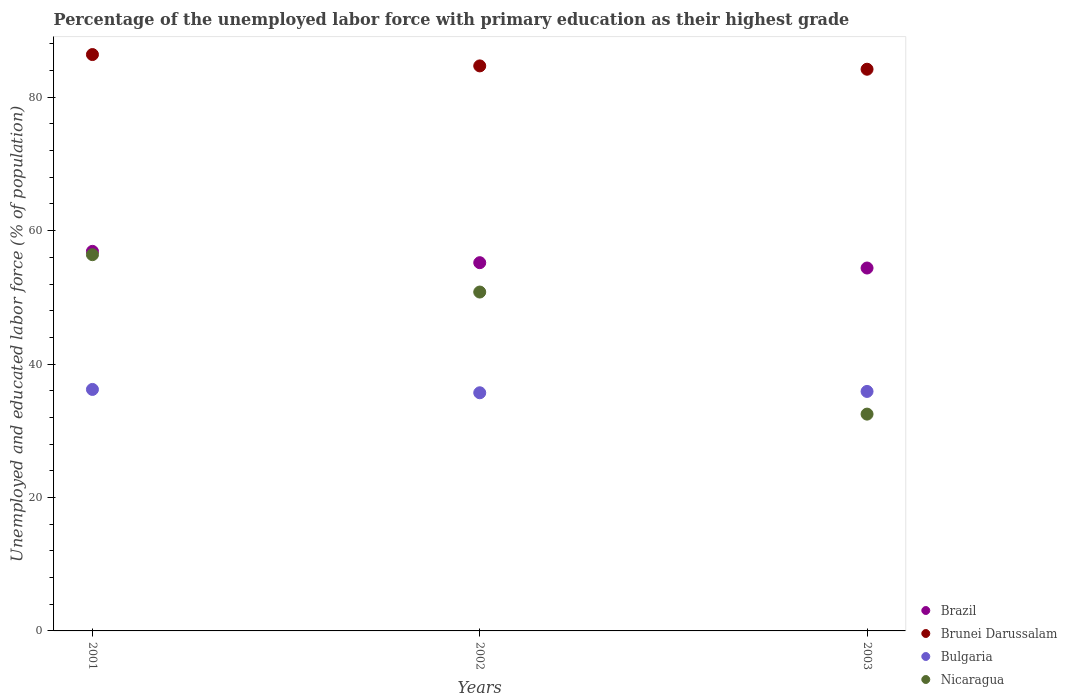How many different coloured dotlines are there?
Your answer should be very brief. 4. What is the percentage of the unemployed labor force with primary education in Nicaragua in 2002?
Provide a succinct answer. 50.8. Across all years, what is the maximum percentage of the unemployed labor force with primary education in Bulgaria?
Keep it short and to the point. 36.2. Across all years, what is the minimum percentage of the unemployed labor force with primary education in Nicaragua?
Your answer should be compact. 32.5. In which year was the percentage of the unemployed labor force with primary education in Nicaragua minimum?
Provide a short and direct response. 2003. What is the total percentage of the unemployed labor force with primary education in Brazil in the graph?
Give a very brief answer. 166.5. What is the difference between the percentage of the unemployed labor force with primary education in Brunei Darussalam in 2001 and that in 2002?
Make the answer very short. 1.7. What is the difference between the percentage of the unemployed labor force with primary education in Brunei Darussalam in 2002 and the percentage of the unemployed labor force with primary education in Brazil in 2001?
Offer a terse response. 27.8. What is the average percentage of the unemployed labor force with primary education in Nicaragua per year?
Offer a terse response. 46.57. In the year 2003, what is the difference between the percentage of the unemployed labor force with primary education in Bulgaria and percentage of the unemployed labor force with primary education in Nicaragua?
Ensure brevity in your answer.  3.4. In how many years, is the percentage of the unemployed labor force with primary education in Brazil greater than 40 %?
Your answer should be very brief. 3. What is the ratio of the percentage of the unemployed labor force with primary education in Bulgaria in 2001 to that in 2003?
Offer a terse response. 1.01. Is the percentage of the unemployed labor force with primary education in Brazil in 2002 less than that in 2003?
Your answer should be very brief. No. What is the difference between the highest and the second highest percentage of the unemployed labor force with primary education in Brazil?
Keep it short and to the point. 1.7. What is the difference between the highest and the lowest percentage of the unemployed labor force with primary education in Bulgaria?
Make the answer very short. 0.5. In how many years, is the percentage of the unemployed labor force with primary education in Brunei Darussalam greater than the average percentage of the unemployed labor force with primary education in Brunei Darussalam taken over all years?
Your answer should be very brief. 1. Is it the case that in every year, the sum of the percentage of the unemployed labor force with primary education in Nicaragua and percentage of the unemployed labor force with primary education in Brazil  is greater than the sum of percentage of the unemployed labor force with primary education in Brunei Darussalam and percentage of the unemployed labor force with primary education in Bulgaria?
Ensure brevity in your answer.  Yes. Is the percentage of the unemployed labor force with primary education in Brunei Darussalam strictly greater than the percentage of the unemployed labor force with primary education in Nicaragua over the years?
Ensure brevity in your answer.  Yes. Is the percentage of the unemployed labor force with primary education in Bulgaria strictly less than the percentage of the unemployed labor force with primary education in Brazil over the years?
Offer a very short reply. Yes. What is the difference between two consecutive major ticks on the Y-axis?
Your answer should be compact. 20. Are the values on the major ticks of Y-axis written in scientific E-notation?
Provide a succinct answer. No. What is the title of the graph?
Offer a very short reply. Percentage of the unemployed labor force with primary education as their highest grade. What is the label or title of the X-axis?
Your answer should be compact. Years. What is the label or title of the Y-axis?
Provide a short and direct response. Unemployed and educated labor force (% of population). What is the Unemployed and educated labor force (% of population) in Brazil in 2001?
Provide a short and direct response. 56.9. What is the Unemployed and educated labor force (% of population) in Brunei Darussalam in 2001?
Give a very brief answer. 86.4. What is the Unemployed and educated labor force (% of population) of Bulgaria in 2001?
Give a very brief answer. 36.2. What is the Unemployed and educated labor force (% of population) of Nicaragua in 2001?
Keep it short and to the point. 56.4. What is the Unemployed and educated labor force (% of population) of Brazil in 2002?
Your answer should be very brief. 55.2. What is the Unemployed and educated labor force (% of population) of Brunei Darussalam in 2002?
Your response must be concise. 84.7. What is the Unemployed and educated labor force (% of population) in Bulgaria in 2002?
Offer a terse response. 35.7. What is the Unemployed and educated labor force (% of population) of Nicaragua in 2002?
Your response must be concise. 50.8. What is the Unemployed and educated labor force (% of population) in Brazil in 2003?
Provide a succinct answer. 54.4. What is the Unemployed and educated labor force (% of population) of Brunei Darussalam in 2003?
Offer a terse response. 84.2. What is the Unemployed and educated labor force (% of population) in Bulgaria in 2003?
Your answer should be compact. 35.9. What is the Unemployed and educated labor force (% of population) of Nicaragua in 2003?
Your response must be concise. 32.5. Across all years, what is the maximum Unemployed and educated labor force (% of population) in Brazil?
Your response must be concise. 56.9. Across all years, what is the maximum Unemployed and educated labor force (% of population) of Brunei Darussalam?
Provide a succinct answer. 86.4. Across all years, what is the maximum Unemployed and educated labor force (% of population) of Bulgaria?
Provide a succinct answer. 36.2. Across all years, what is the maximum Unemployed and educated labor force (% of population) of Nicaragua?
Ensure brevity in your answer.  56.4. Across all years, what is the minimum Unemployed and educated labor force (% of population) in Brazil?
Offer a very short reply. 54.4. Across all years, what is the minimum Unemployed and educated labor force (% of population) of Brunei Darussalam?
Make the answer very short. 84.2. Across all years, what is the minimum Unemployed and educated labor force (% of population) of Bulgaria?
Give a very brief answer. 35.7. Across all years, what is the minimum Unemployed and educated labor force (% of population) of Nicaragua?
Your response must be concise. 32.5. What is the total Unemployed and educated labor force (% of population) of Brazil in the graph?
Keep it short and to the point. 166.5. What is the total Unemployed and educated labor force (% of population) of Brunei Darussalam in the graph?
Make the answer very short. 255.3. What is the total Unemployed and educated labor force (% of population) in Bulgaria in the graph?
Give a very brief answer. 107.8. What is the total Unemployed and educated labor force (% of population) in Nicaragua in the graph?
Provide a short and direct response. 139.7. What is the difference between the Unemployed and educated labor force (% of population) of Brazil in 2001 and that in 2002?
Provide a succinct answer. 1.7. What is the difference between the Unemployed and educated labor force (% of population) in Nicaragua in 2001 and that in 2002?
Keep it short and to the point. 5.6. What is the difference between the Unemployed and educated labor force (% of population) in Brazil in 2001 and that in 2003?
Keep it short and to the point. 2.5. What is the difference between the Unemployed and educated labor force (% of population) of Bulgaria in 2001 and that in 2003?
Provide a short and direct response. 0.3. What is the difference between the Unemployed and educated labor force (% of population) in Nicaragua in 2001 and that in 2003?
Ensure brevity in your answer.  23.9. What is the difference between the Unemployed and educated labor force (% of population) of Brazil in 2002 and that in 2003?
Your answer should be very brief. 0.8. What is the difference between the Unemployed and educated labor force (% of population) in Brunei Darussalam in 2002 and that in 2003?
Your answer should be compact. 0.5. What is the difference between the Unemployed and educated labor force (% of population) in Bulgaria in 2002 and that in 2003?
Give a very brief answer. -0.2. What is the difference between the Unemployed and educated labor force (% of population) of Nicaragua in 2002 and that in 2003?
Make the answer very short. 18.3. What is the difference between the Unemployed and educated labor force (% of population) in Brazil in 2001 and the Unemployed and educated labor force (% of population) in Brunei Darussalam in 2002?
Your answer should be compact. -27.8. What is the difference between the Unemployed and educated labor force (% of population) in Brazil in 2001 and the Unemployed and educated labor force (% of population) in Bulgaria in 2002?
Your answer should be compact. 21.2. What is the difference between the Unemployed and educated labor force (% of population) in Brazil in 2001 and the Unemployed and educated labor force (% of population) in Nicaragua in 2002?
Your response must be concise. 6.1. What is the difference between the Unemployed and educated labor force (% of population) of Brunei Darussalam in 2001 and the Unemployed and educated labor force (% of population) of Bulgaria in 2002?
Provide a succinct answer. 50.7. What is the difference between the Unemployed and educated labor force (% of population) in Brunei Darussalam in 2001 and the Unemployed and educated labor force (% of population) in Nicaragua in 2002?
Offer a terse response. 35.6. What is the difference between the Unemployed and educated labor force (% of population) in Bulgaria in 2001 and the Unemployed and educated labor force (% of population) in Nicaragua in 2002?
Ensure brevity in your answer.  -14.6. What is the difference between the Unemployed and educated labor force (% of population) in Brazil in 2001 and the Unemployed and educated labor force (% of population) in Brunei Darussalam in 2003?
Offer a very short reply. -27.3. What is the difference between the Unemployed and educated labor force (% of population) in Brazil in 2001 and the Unemployed and educated labor force (% of population) in Nicaragua in 2003?
Keep it short and to the point. 24.4. What is the difference between the Unemployed and educated labor force (% of population) in Brunei Darussalam in 2001 and the Unemployed and educated labor force (% of population) in Bulgaria in 2003?
Give a very brief answer. 50.5. What is the difference between the Unemployed and educated labor force (% of population) in Brunei Darussalam in 2001 and the Unemployed and educated labor force (% of population) in Nicaragua in 2003?
Provide a short and direct response. 53.9. What is the difference between the Unemployed and educated labor force (% of population) in Bulgaria in 2001 and the Unemployed and educated labor force (% of population) in Nicaragua in 2003?
Offer a terse response. 3.7. What is the difference between the Unemployed and educated labor force (% of population) of Brazil in 2002 and the Unemployed and educated labor force (% of population) of Brunei Darussalam in 2003?
Your answer should be compact. -29. What is the difference between the Unemployed and educated labor force (% of population) of Brazil in 2002 and the Unemployed and educated labor force (% of population) of Bulgaria in 2003?
Provide a short and direct response. 19.3. What is the difference between the Unemployed and educated labor force (% of population) in Brazil in 2002 and the Unemployed and educated labor force (% of population) in Nicaragua in 2003?
Provide a short and direct response. 22.7. What is the difference between the Unemployed and educated labor force (% of population) of Brunei Darussalam in 2002 and the Unemployed and educated labor force (% of population) of Bulgaria in 2003?
Your answer should be compact. 48.8. What is the difference between the Unemployed and educated labor force (% of population) in Brunei Darussalam in 2002 and the Unemployed and educated labor force (% of population) in Nicaragua in 2003?
Provide a short and direct response. 52.2. What is the average Unemployed and educated labor force (% of population) of Brazil per year?
Your response must be concise. 55.5. What is the average Unemployed and educated labor force (% of population) in Brunei Darussalam per year?
Your answer should be very brief. 85.1. What is the average Unemployed and educated labor force (% of population) in Bulgaria per year?
Keep it short and to the point. 35.93. What is the average Unemployed and educated labor force (% of population) of Nicaragua per year?
Your answer should be very brief. 46.57. In the year 2001, what is the difference between the Unemployed and educated labor force (% of population) of Brazil and Unemployed and educated labor force (% of population) of Brunei Darussalam?
Keep it short and to the point. -29.5. In the year 2001, what is the difference between the Unemployed and educated labor force (% of population) of Brazil and Unemployed and educated labor force (% of population) of Bulgaria?
Your answer should be very brief. 20.7. In the year 2001, what is the difference between the Unemployed and educated labor force (% of population) in Brazil and Unemployed and educated labor force (% of population) in Nicaragua?
Offer a terse response. 0.5. In the year 2001, what is the difference between the Unemployed and educated labor force (% of population) in Brunei Darussalam and Unemployed and educated labor force (% of population) in Bulgaria?
Your answer should be very brief. 50.2. In the year 2001, what is the difference between the Unemployed and educated labor force (% of population) in Bulgaria and Unemployed and educated labor force (% of population) in Nicaragua?
Your answer should be compact. -20.2. In the year 2002, what is the difference between the Unemployed and educated labor force (% of population) of Brazil and Unemployed and educated labor force (% of population) of Brunei Darussalam?
Provide a succinct answer. -29.5. In the year 2002, what is the difference between the Unemployed and educated labor force (% of population) in Brunei Darussalam and Unemployed and educated labor force (% of population) in Nicaragua?
Provide a short and direct response. 33.9. In the year 2002, what is the difference between the Unemployed and educated labor force (% of population) of Bulgaria and Unemployed and educated labor force (% of population) of Nicaragua?
Give a very brief answer. -15.1. In the year 2003, what is the difference between the Unemployed and educated labor force (% of population) of Brazil and Unemployed and educated labor force (% of population) of Brunei Darussalam?
Make the answer very short. -29.8. In the year 2003, what is the difference between the Unemployed and educated labor force (% of population) of Brazil and Unemployed and educated labor force (% of population) of Nicaragua?
Make the answer very short. 21.9. In the year 2003, what is the difference between the Unemployed and educated labor force (% of population) in Brunei Darussalam and Unemployed and educated labor force (% of population) in Bulgaria?
Provide a short and direct response. 48.3. In the year 2003, what is the difference between the Unemployed and educated labor force (% of population) in Brunei Darussalam and Unemployed and educated labor force (% of population) in Nicaragua?
Give a very brief answer. 51.7. What is the ratio of the Unemployed and educated labor force (% of population) of Brazil in 2001 to that in 2002?
Offer a terse response. 1.03. What is the ratio of the Unemployed and educated labor force (% of population) of Brunei Darussalam in 2001 to that in 2002?
Make the answer very short. 1.02. What is the ratio of the Unemployed and educated labor force (% of population) in Nicaragua in 2001 to that in 2002?
Offer a very short reply. 1.11. What is the ratio of the Unemployed and educated labor force (% of population) of Brazil in 2001 to that in 2003?
Keep it short and to the point. 1.05. What is the ratio of the Unemployed and educated labor force (% of population) of Brunei Darussalam in 2001 to that in 2003?
Your answer should be compact. 1.03. What is the ratio of the Unemployed and educated labor force (% of population) of Bulgaria in 2001 to that in 2003?
Provide a succinct answer. 1.01. What is the ratio of the Unemployed and educated labor force (% of population) in Nicaragua in 2001 to that in 2003?
Your answer should be very brief. 1.74. What is the ratio of the Unemployed and educated labor force (% of population) in Brazil in 2002 to that in 2003?
Provide a short and direct response. 1.01. What is the ratio of the Unemployed and educated labor force (% of population) in Brunei Darussalam in 2002 to that in 2003?
Give a very brief answer. 1.01. What is the ratio of the Unemployed and educated labor force (% of population) of Bulgaria in 2002 to that in 2003?
Provide a succinct answer. 0.99. What is the ratio of the Unemployed and educated labor force (% of population) of Nicaragua in 2002 to that in 2003?
Provide a short and direct response. 1.56. What is the difference between the highest and the second highest Unemployed and educated labor force (% of population) in Brazil?
Keep it short and to the point. 1.7. What is the difference between the highest and the second highest Unemployed and educated labor force (% of population) in Brunei Darussalam?
Your answer should be very brief. 1.7. What is the difference between the highest and the second highest Unemployed and educated labor force (% of population) in Bulgaria?
Offer a terse response. 0.3. What is the difference between the highest and the second highest Unemployed and educated labor force (% of population) in Nicaragua?
Ensure brevity in your answer.  5.6. What is the difference between the highest and the lowest Unemployed and educated labor force (% of population) in Brunei Darussalam?
Your answer should be compact. 2.2. What is the difference between the highest and the lowest Unemployed and educated labor force (% of population) in Nicaragua?
Your answer should be very brief. 23.9. 